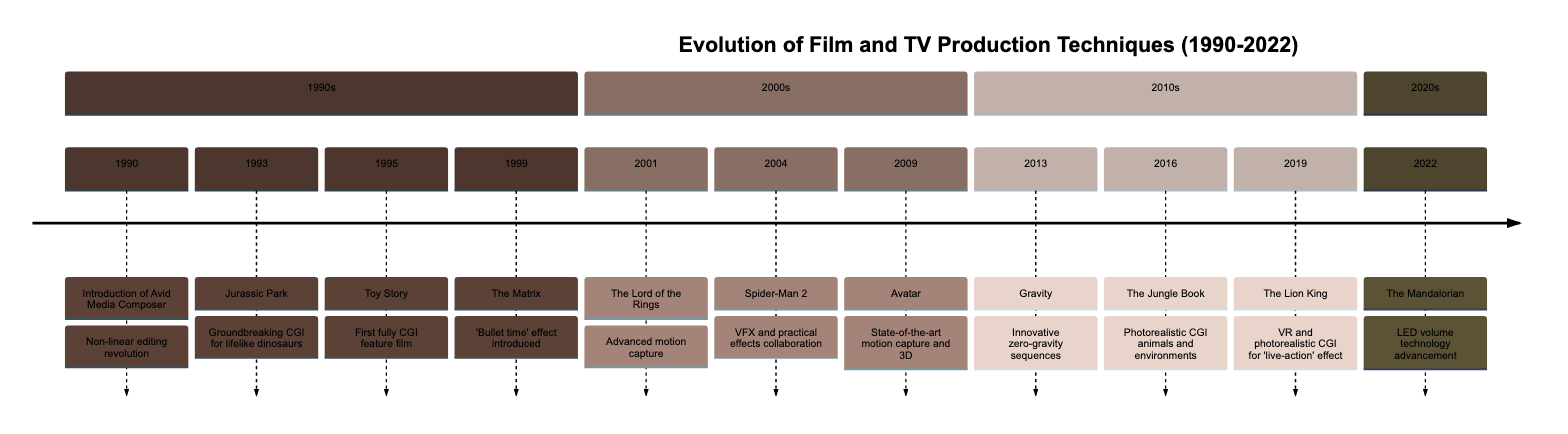What year was Jurassic Park released? The event for Jurassic Park is listed under the year 1993 in the timeline.
Answer: 1993 What is the significance of Toy Story in film history? The timeline specifies that Toy Story was the first fully CGI feature film, marking a significant evolutionary step in animation.
Answer: First fully CGI feature film How many events are listed for the 2000s? By counting the events in the 2000s section, there are three events noted: The Lord of the Rings, Spider-Man 2, and Avatar.
Answer: 3 What advanced technology was utilized in The Mandalorian? The event description for The Mandalorian mentions the use of LED volume technology to create immersive environments, which is a modern production technique.
Answer: LED volume technology Which film introduced the 'bullet time' effect? In the timeline, The Matrix is noted for introducing the 'bullet time' effect, a significant innovation in cinematic techniques.
Answer: The Matrix Explain the relationship between Spider-Man 2 and its visual effects. The timeline indicates that Spider-Man 2 combined VFX and practical effects, which is significant as it shows the collaboration between different filmmaking techniques to enhance realism.
Answer: Combined VFX and practical effects What unique blend was showcased in The Jungle Book? The event for The Jungle Book describes it as showcasing a blend of live-action performances and photorealistic CGI animals and environments, highlighting the integration of different techniques.
Answer: Live-action and photorealistic CGI In what year did the first feature-length CGI film come out? The timeline indicates that Toy Story, which is the first feature-length CGI film, was released in 1995.
Answer: 1995 How many Academy Awards did Gravity win for its visual effects? The timeline states that Gravity won multiple Academy Awards, implying a significant recognition of its innovative visual effects, but does not specify a number.
Answer: Multiple Academy Awards 